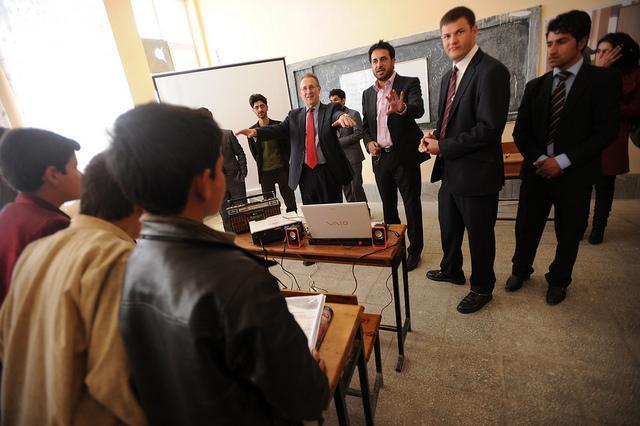How many men are wearing ties?
Give a very brief answer. 3. How many people are shown?
Give a very brief answer. 11. How many people are there?
Give a very brief answer. 10. 